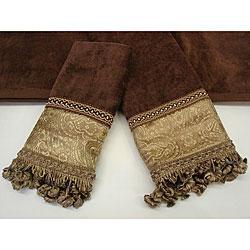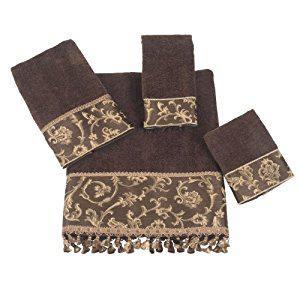The first image is the image on the left, the second image is the image on the right. Analyze the images presented: Is the assertion "There are towels with flanges on the bottom facing downward." valid? Answer yes or no. Yes. 